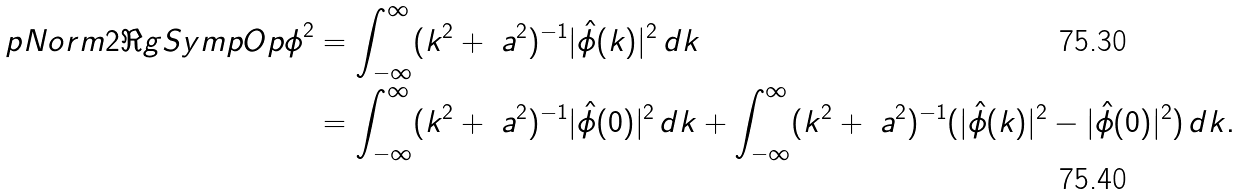<formula> <loc_0><loc_0><loc_500><loc_500>\L p N o r m { 2 } { \Re g S y m p O p \phi } ^ { 2 } & = \int _ { - \infty } ^ { \infty } ( k ^ { 2 } + \ a ^ { 2 } ) ^ { - 1 } | \hat { \phi } ( k ) | ^ { 2 } \, d k \\ & = \int _ { - \infty } ^ { \infty } ( k ^ { 2 } + \ a ^ { 2 } ) ^ { - 1 } | \hat { \phi } ( 0 ) | ^ { 2 } \, d k + \int _ { - \infty } ^ { \infty } ( k ^ { 2 } + \ a ^ { 2 } ) ^ { - 1 } ( | \hat { \phi } ( k ) | ^ { 2 } - | \hat { \phi } ( 0 ) | ^ { 2 } ) \, d k .</formula> 